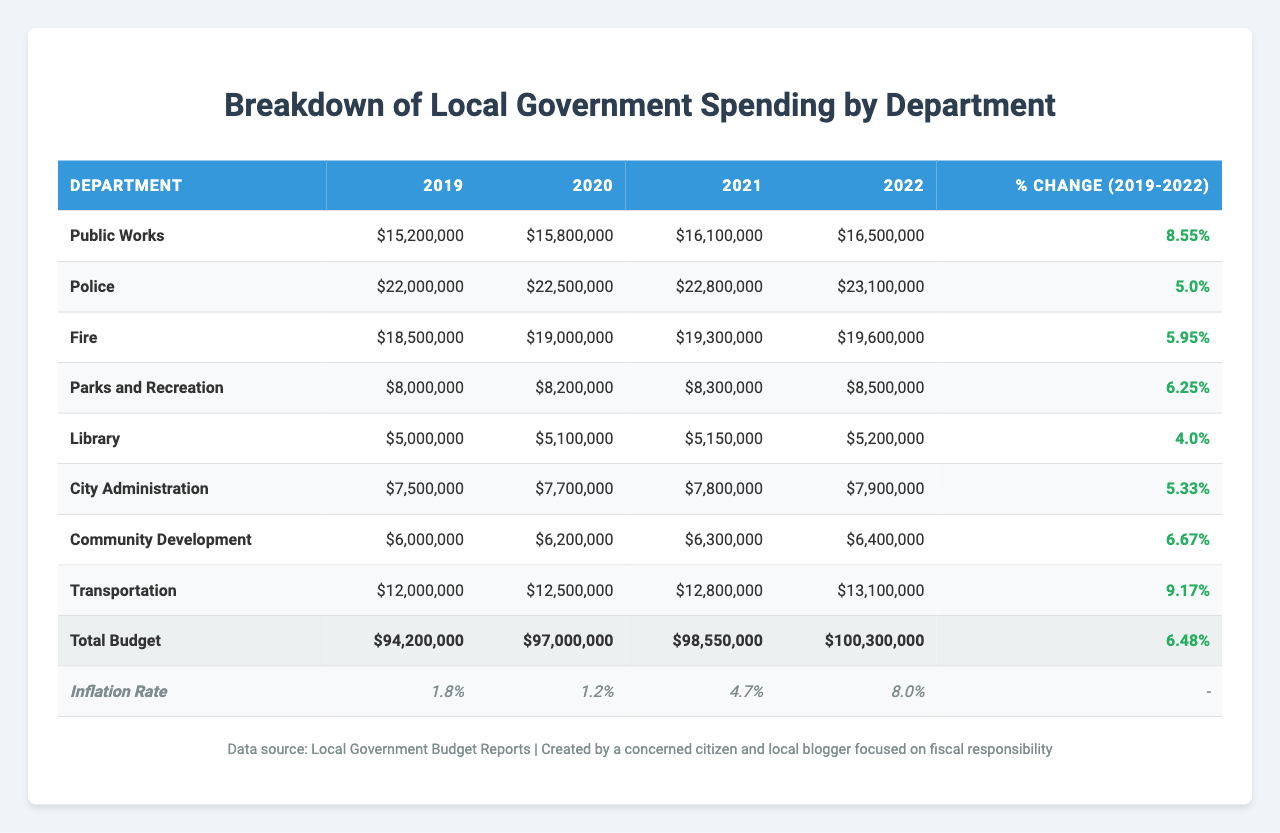What was the total spending by the Police department in 2021? The table shows that the spending by the Police department in 2021 was $22,800,000.
Answer: $22,800,000 Which department had the highest percentage increase in spending from 2019 to 2022? Looking at the percent change column, the Transportation department had the highest percentage increase of 9.17%.
Answer: Transportation What was the total budget for all departments in 2020? The table lists the total budget for 2020 as $97,000,000.
Answer: $97,000,000 Did the Library department see an increase in funding every year from 2019 to 2022? The table shows an increase each year for the Library: $5,000,000 (2019) to $5,200,000 (2022), indicating consistent annual increases.
Answer: Yes What is the combined spending of the Fire and Parks and Recreation departments in 2022? The Fire department's spending in 2022 was $19,600,000, and Parks and Recreation's was $8,500,000. Their combined spending is $19,600,000 + $8,500,000 = $28,100,000.
Answer: $28,100,000 How much did the City Administration department spend in 2021 compared to 2019? The table reveals that the City Administration spent $7,800,000 in 2021, which is an increase from $7,500,000 in 2019. The difference is $7,800,000 - $7,500,000 = $300,000.
Answer: $300,000 increase What was the inflation rate in 2021, and how does it compare to the inflation rate in 2022? The inflation rate in 2021 was 4.7%, while in 2022 it increased to 8.0%, indicating an upward trend in inflation.
Answer: 4.7% in 2021; 8.0% in 2022 If the total budget increased from 2019 to 2022, by how much did it increase in absolute terms? The total budget in 2019 was $94,200,000, and in 2022 it was $100,300,000. The increase is $100,300,000 - $94,200,000 = $6,100,000.
Answer: $6,100,000 What is the average spending per department for 2022? The total budget for 2022 was $100,300,000, and there are 8 departments, so the average is $100,300,000 / 8 = $12,537,500.
Answer: $12,537,500 Which department experienced the least growth in spending over the four years? The Library department had the lowest percent change in spending at 4.00%.
Answer: Library 